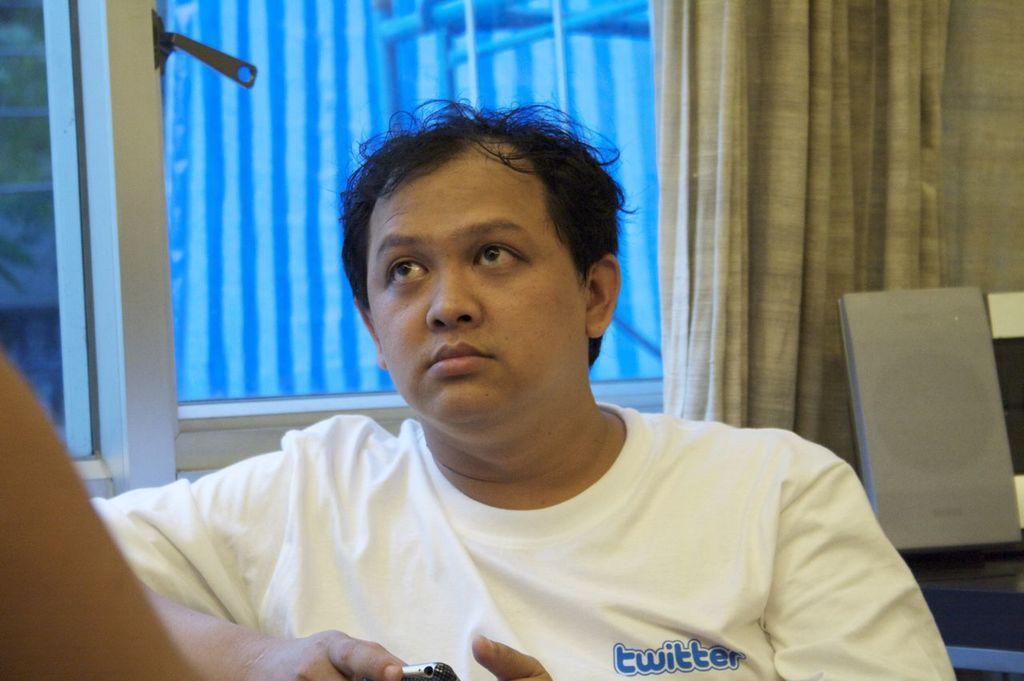Describe this image in one or two sentences. In the foreground of this image, there is a man in white T shirt holding a mobile. In the background, there is a window, curtain and few objects. On the left, there is a hand. 